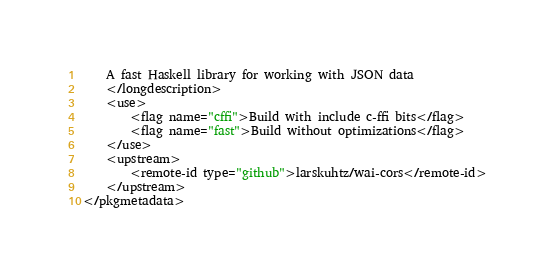Convert code to text. <code><loc_0><loc_0><loc_500><loc_500><_XML_>	A fast Haskell library for working with JSON data
	</longdescription>
	<use>
		<flag name="cffi">Build with include c-ffi bits</flag>
		<flag name="fast">Build without optimizations</flag>
	</use>
	<upstream>
		<remote-id type="github">larskuhtz/wai-cors</remote-id>
	</upstream>
</pkgmetadata>
</code> 